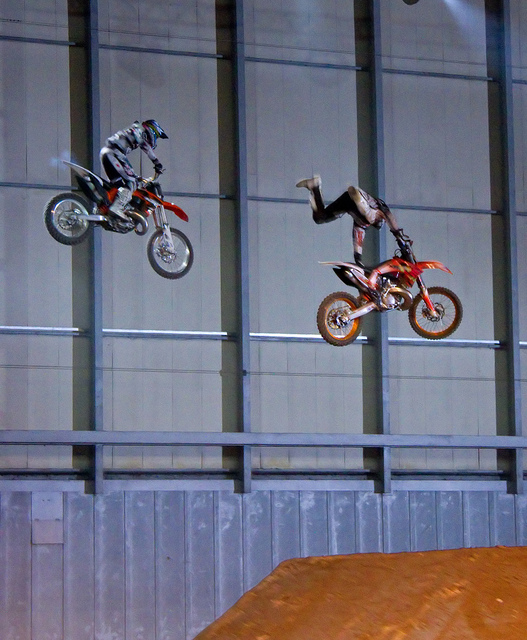How many motorcycles are there? 2 